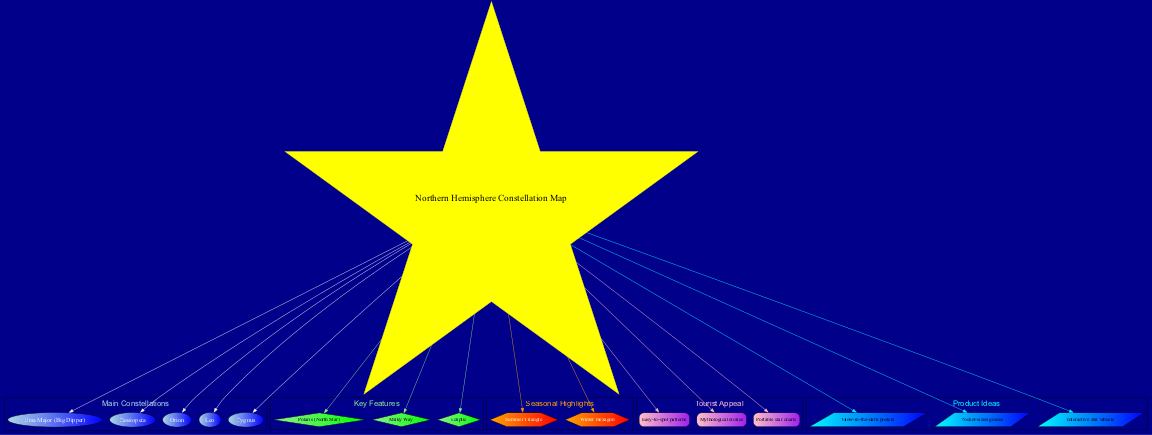What are the main constellations shown in this diagram? The diagram explicitly lists the main constellations, which are located near the central topic and connected to it. The constellations include Ursa Major, Cassiopeia, Orion, Leo, and Cygnus. Therefore, by identifying these nodes, we can list the main constellations.
Answer: Ursa Major, Cassiopeia, Orion, Leo, Cygnus How many key features are represented in the diagram? In the diagram, the key features are categorized under a specific cluster. There are three nodes under the 'Key Features' section: Polaris, Milky Way, and Ecliptic. Therefore, counting these nodes will give the total number of key features shown.
Answer: 3 Which seasonal highlight is connected to the central topic? The diagram structures connections from the central topic to the 'Seasonal Highlights' section. The seasonal highlights include the Summer Triangle and the Winter Hexagon. Therefore, both seasonal highlights are linked to the central topic.
Answer: Summer Triangle, Winter Hexagon What color represents the main constellations in this diagram? The nodes representing the main constellations are indicated in light blue and blue. Since these colors are specified for the cluster of main constellations within the diagram, we identify that light blue and blue are used there.
Answer: Light blue, blue Are there any tourist appeal features that involve merchandise ideas? The diagram shows a section for 'Tourist Appeal,' which includes features like Easy-to-spot patterns, Mythological stories, and Portable star charts. Some of these features directly suggest that they could influence merchandise ideas. For instance, the portable star charts allow for easy access to stargazing, indicating a connection to tourist merchandise.
Answer: Yes What shape is used for the product ideas section of the diagram? The product ideas are placed under a specific cluster that utilizes a shape distinctively marked as a parallelogram. This shape is specified within the diagram's structure for the product ideas, making it recognizable as such.
Answer: Parallelogram Which two constellations are known for their prominence in the Northern Hemisphere? The diagram specifies that Ursa Major and Orion are among the main constellations. Both are widely recognized for their visibility in the Northern Hemisphere, making them prominent choices for stargazing. Thus, identifying them from the constellation list enables answering the question.
Answer: Ursa Major, Orion What two colors represent the tourist appeal cluster? Identifying the tourist appeal section reveals distinct colors, specifically pink and purple, which are used in the nodes of that cluster. Noting the attributes of each node allows us to pinpoint the color representation in the diagram.
Answer: Pink, purple 